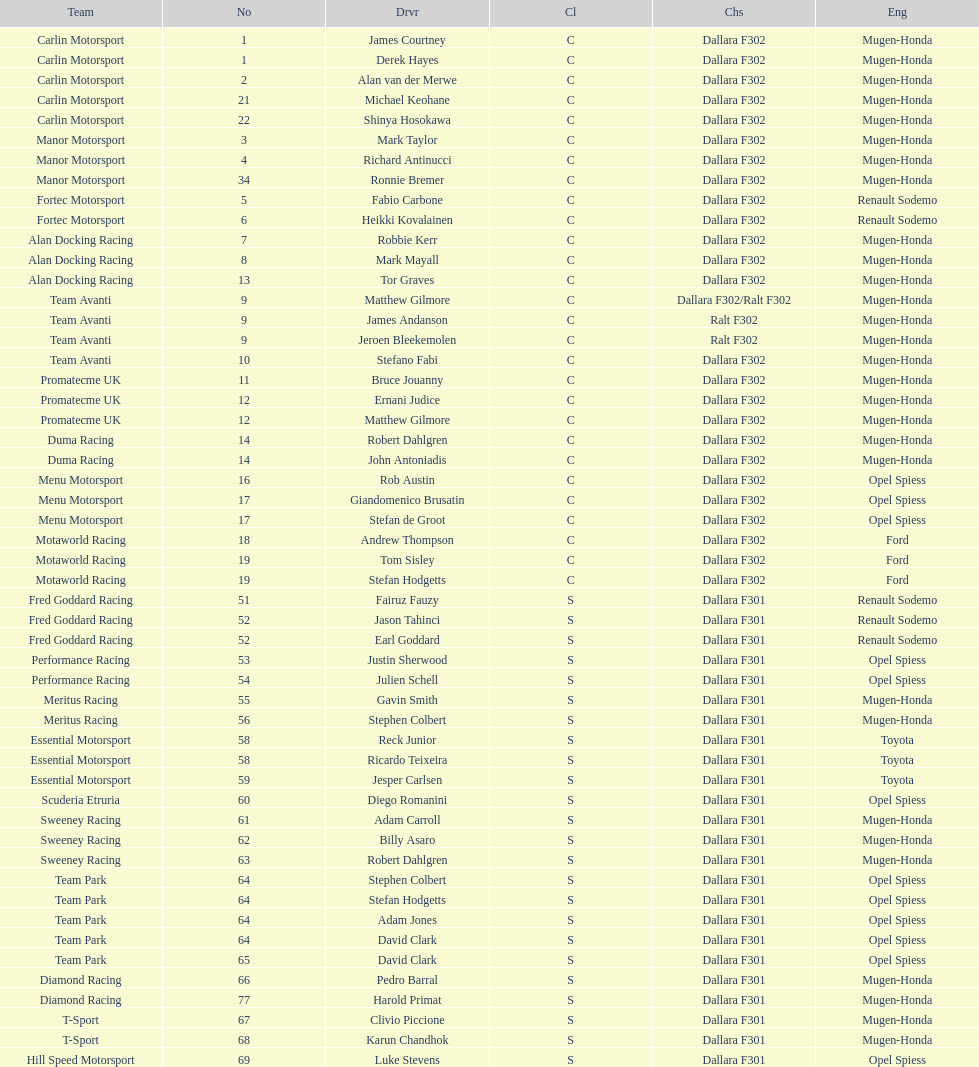How many class s (scholarship) teams are on the chart? 19. 